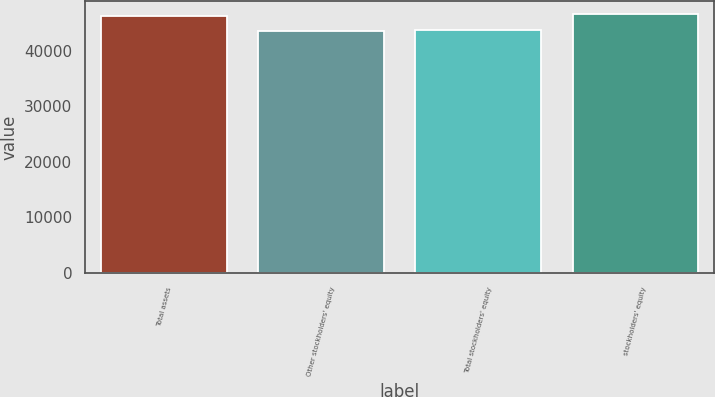Convert chart to OTSL. <chart><loc_0><loc_0><loc_500><loc_500><bar_chart><fcel>Total assets<fcel>Other stockholders' equity<fcel>Total stockholders' equity<fcel>stockholders' equity<nl><fcel>46314<fcel>43536<fcel>43813.8<fcel>46591.8<nl></chart> 